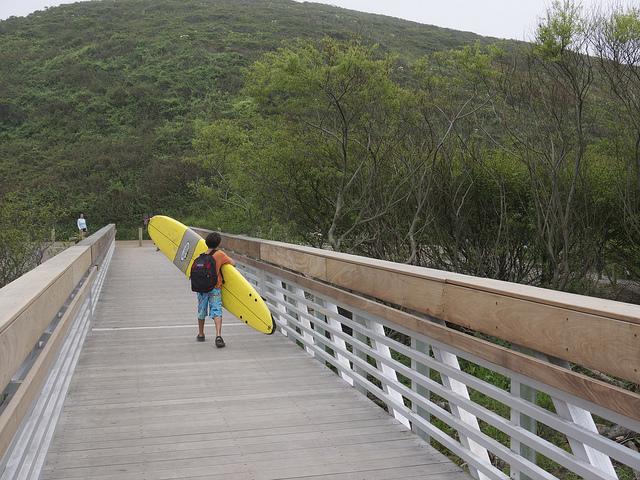What color is the surfboard?
Be succinct. Yellow. Is there water in this shot?
Quick response, please. No. Is the man carrying a skateboard?
Keep it brief. No. 